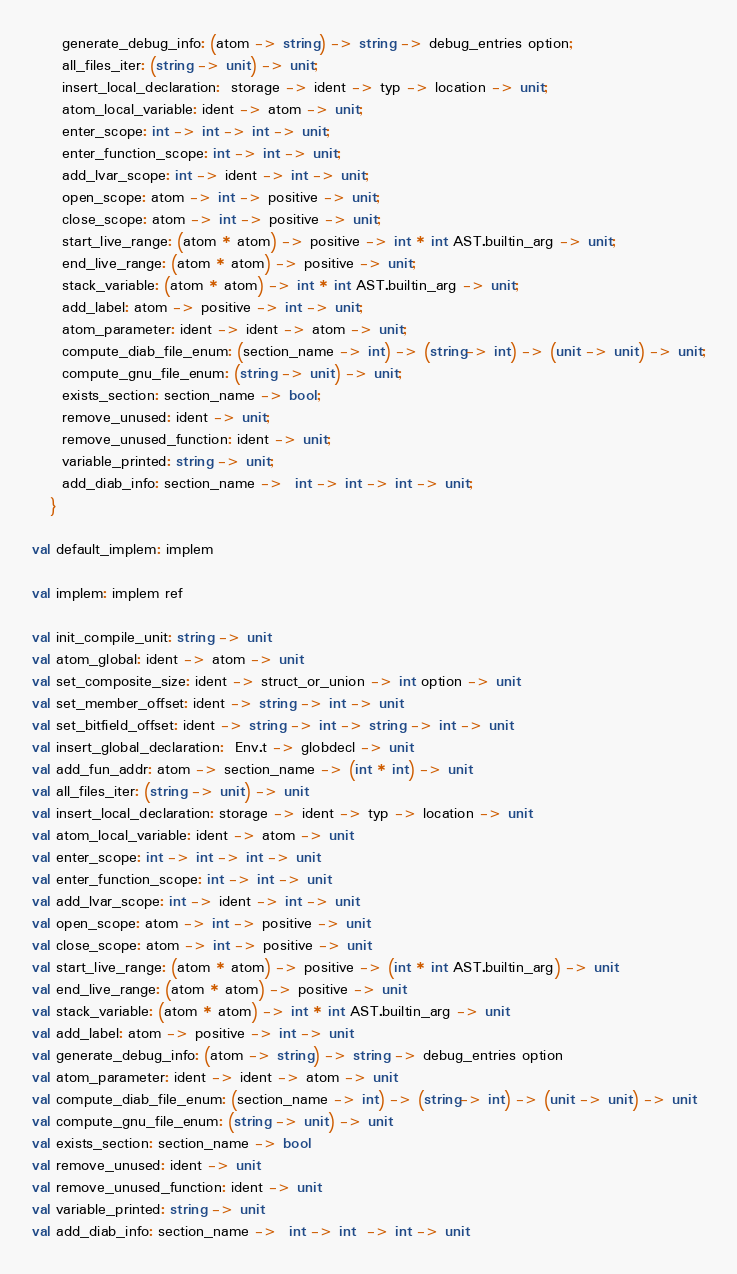Convert code to text. <code><loc_0><loc_0><loc_500><loc_500><_OCaml_>     generate_debug_info: (atom -> string) -> string -> debug_entries option;
     all_files_iter: (string -> unit) -> unit;
     insert_local_declaration:  storage -> ident -> typ -> location -> unit;
     atom_local_variable: ident -> atom -> unit;
     enter_scope: int -> int -> int -> unit;
     enter_function_scope: int -> int -> unit;
     add_lvar_scope: int -> ident -> int -> unit;
     open_scope: atom -> int -> positive -> unit;
     close_scope: atom -> int -> positive -> unit;
     start_live_range: (atom * atom) -> positive -> int * int AST.builtin_arg -> unit;
     end_live_range: (atom * atom) -> positive -> unit;
     stack_variable: (atom * atom) -> int * int AST.builtin_arg -> unit;
     add_label: atom -> positive -> int -> unit;
     atom_parameter: ident -> ident -> atom -> unit;
     compute_diab_file_enum: (section_name -> int) -> (string-> int) -> (unit -> unit) -> unit;
     compute_gnu_file_enum: (string -> unit) -> unit;
     exists_section: section_name -> bool;
     remove_unused: ident -> unit;
     remove_unused_function: ident -> unit;
     variable_printed: string -> unit;
     add_diab_info: section_name ->  int -> int -> int -> unit;
   }

val default_implem: implem

val implem: implem ref

val init_compile_unit: string -> unit
val atom_global: ident -> atom -> unit
val set_composite_size: ident -> struct_or_union -> int option -> unit
val set_member_offset: ident -> string -> int -> unit
val set_bitfield_offset: ident -> string -> int -> string -> int -> unit
val insert_global_declaration:  Env.t -> globdecl -> unit
val add_fun_addr: atom -> section_name -> (int * int) -> unit
val all_files_iter: (string -> unit) -> unit
val insert_local_declaration: storage -> ident -> typ -> location -> unit
val atom_local_variable: ident -> atom -> unit
val enter_scope: int -> int -> int -> unit
val enter_function_scope: int -> int -> unit
val add_lvar_scope: int -> ident -> int -> unit
val open_scope: atom -> int -> positive -> unit
val close_scope: atom -> int -> positive -> unit
val start_live_range: (atom * atom) -> positive -> (int * int AST.builtin_arg) -> unit
val end_live_range: (atom * atom) -> positive -> unit
val stack_variable: (atom * atom) -> int * int AST.builtin_arg -> unit
val add_label: atom -> positive -> int -> unit
val generate_debug_info: (atom -> string) -> string -> debug_entries option
val atom_parameter: ident -> ident -> atom -> unit
val compute_diab_file_enum: (section_name -> int) -> (string-> int) -> (unit -> unit) -> unit
val compute_gnu_file_enum: (string -> unit) -> unit
val exists_section: section_name -> bool
val remove_unused: ident -> unit
val remove_unused_function: ident -> unit
val variable_printed: string -> unit
val add_diab_info: section_name ->  int -> int  -> int -> unit
</code> 